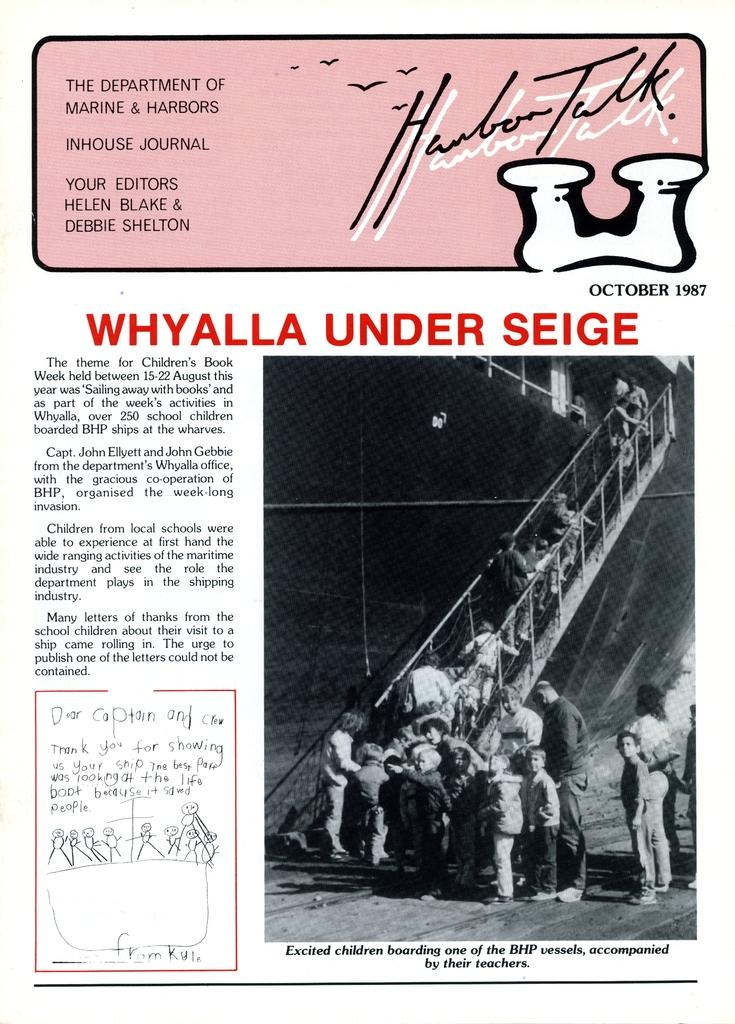Provide a one-sentence caption for the provided image. whylla under seige flyer it looks old from while ago. 